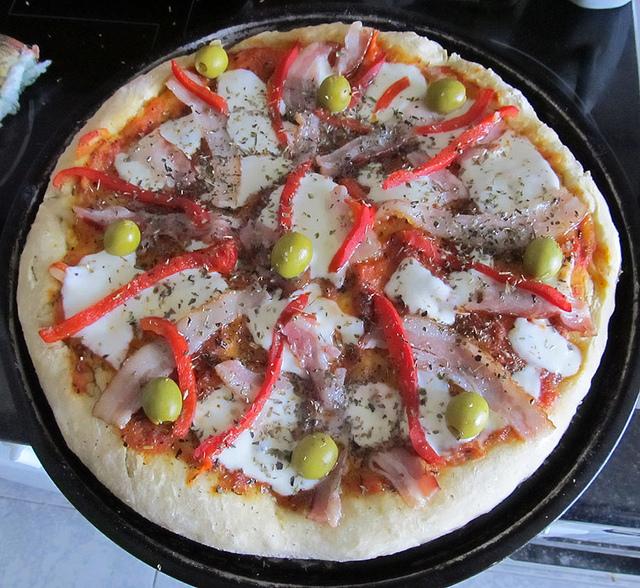What is red on the pizza?
Give a very brief answer. Peppers. What are the red stripes on the pizza?
Write a very short answer. Peppers. What is the table made of?
Answer briefly. Glass. What are the green things on the pizza?
Keep it brief. Olives. Is the pizza still raw or ready to eat?
Quick response, please. Raw. 